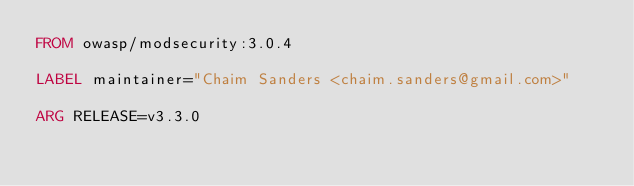<code> <loc_0><loc_0><loc_500><loc_500><_Dockerfile_>FROM owasp/modsecurity:3.0.4

LABEL maintainer="Chaim Sanders <chaim.sanders@gmail.com>"

ARG RELEASE=v3.3.0
</code> 